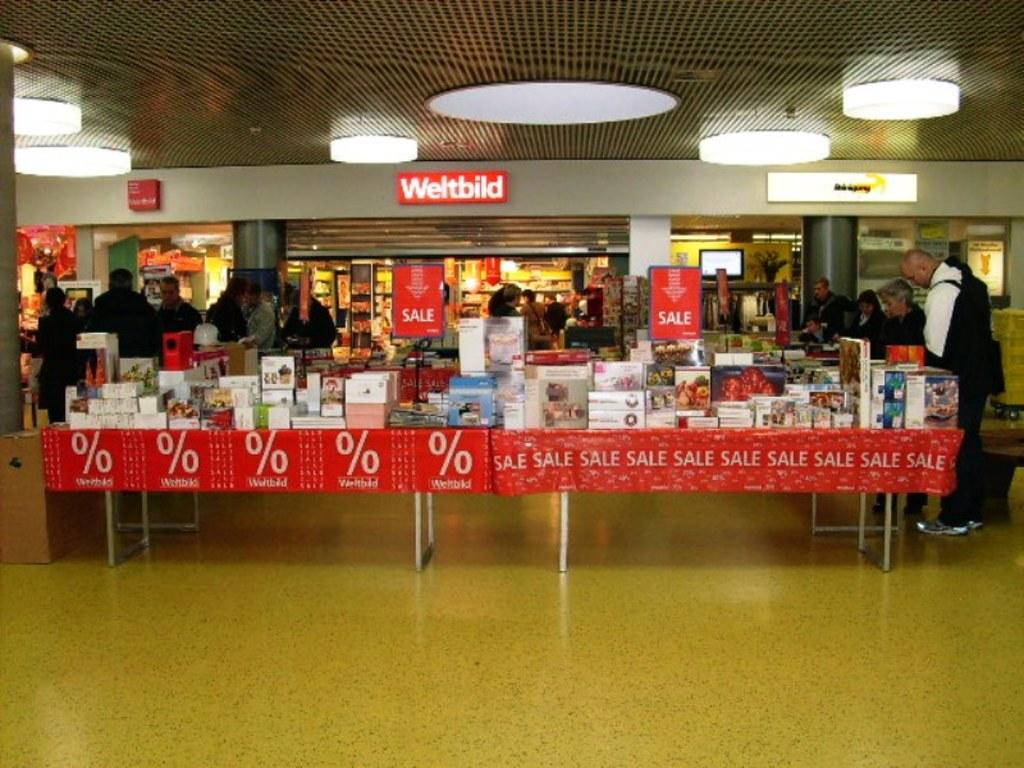<image>
Relay a brief, clear account of the picture shown. A store called Weltbild has a sale outside of the store. 